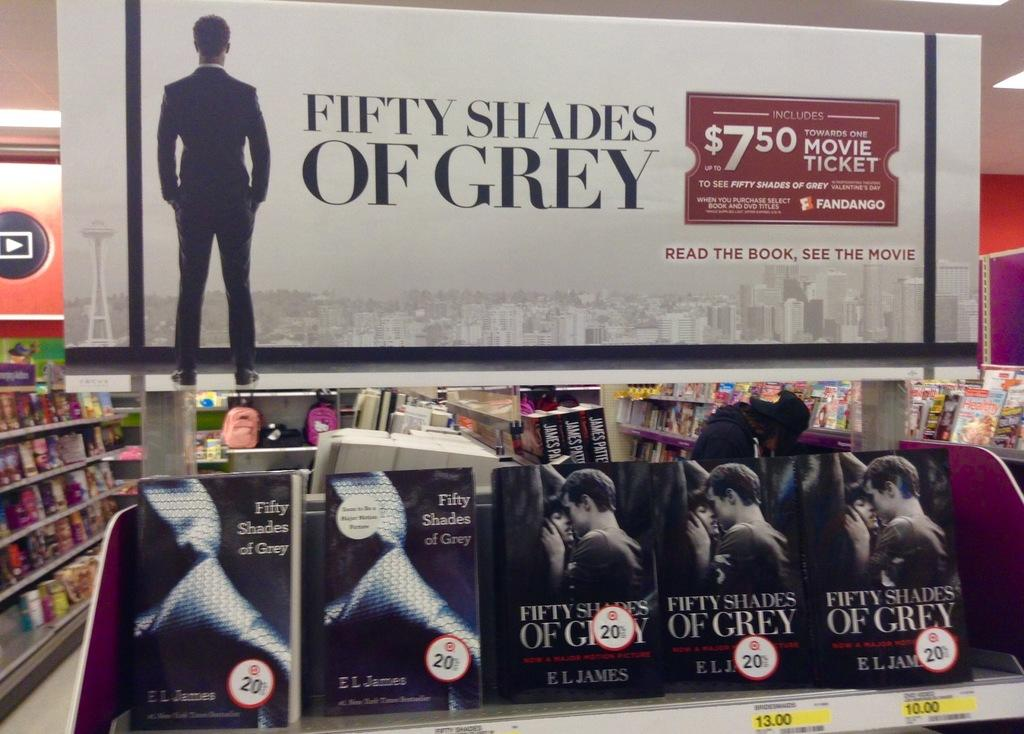What type of reading material is visible in the image? There is a group of magazines placed in a rack and different books placed in different racks. How are the magazines and books organized in the image? The magazines are placed in a rack, and the books are placed in different racks. What can be seen in the background of the image? There is a sign board in the background. What type of drink is being served in the image? There is no drink being served in the image; it features a group of magazines and books placed in racks with a sign board in the background. Can you describe the ray of light shining on the books in the image? There is no ray of light shining on the books in the image; the lighting is consistent throughout the scene. 